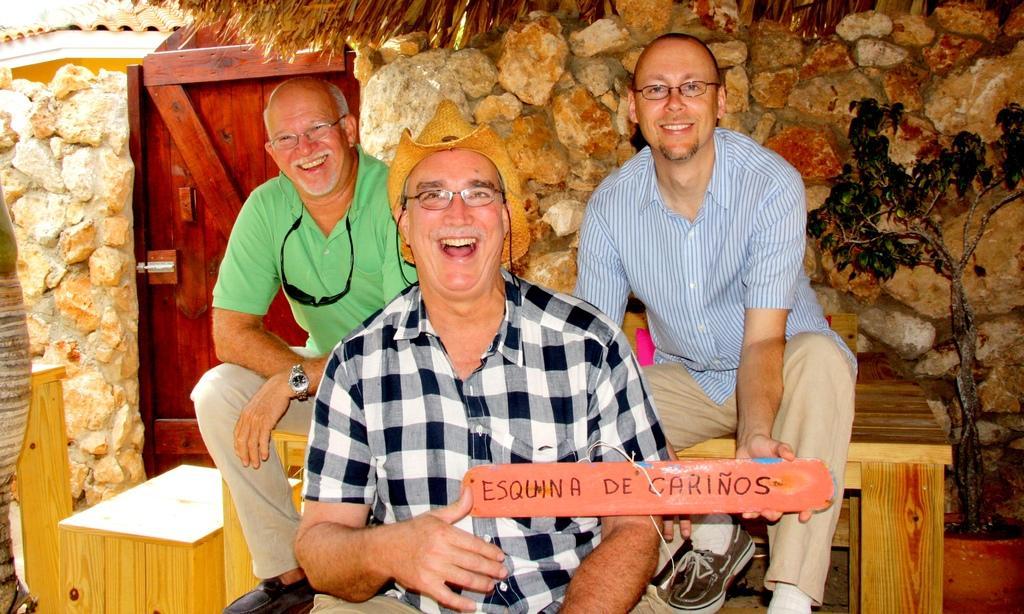Describe this image in one or two sentences. In this image we can see three persons wearing checked shirt and a person wearing green color T-shirt also wearing black color goggles, all three are sitting on the benches and in the background of the image we can see stonewall, door which is of brown color and there is a tree. 